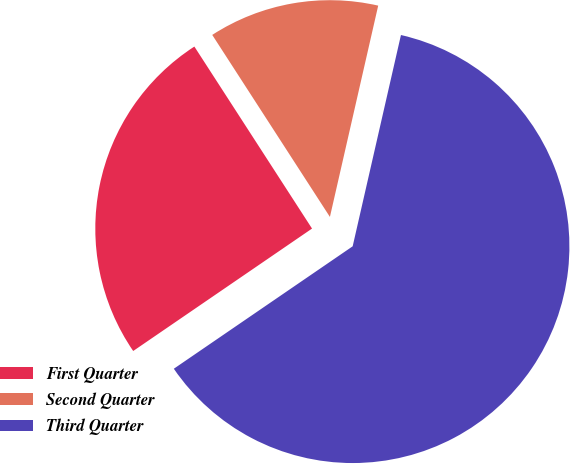Convert chart to OTSL. <chart><loc_0><loc_0><loc_500><loc_500><pie_chart><fcel>First Quarter<fcel>Second Quarter<fcel>Third Quarter<nl><fcel>25.42%<fcel>12.71%<fcel>61.87%<nl></chart> 